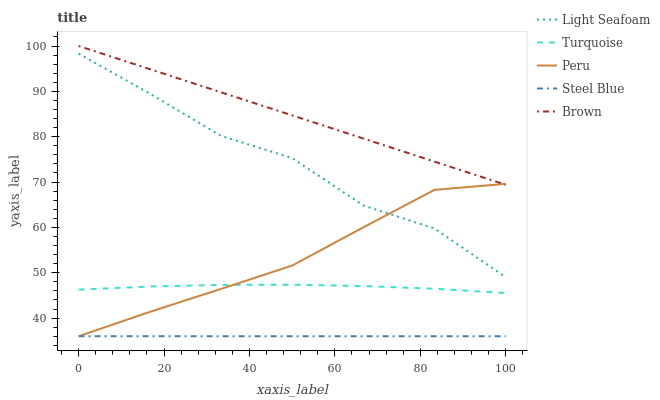Does Steel Blue have the minimum area under the curve?
Answer yes or no. Yes. Does Brown have the maximum area under the curve?
Answer yes or no. Yes. Does Turquoise have the minimum area under the curve?
Answer yes or no. No. Does Turquoise have the maximum area under the curve?
Answer yes or no. No. Is Brown the smoothest?
Answer yes or no. Yes. Is Light Seafoam the roughest?
Answer yes or no. Yes. Is Turquoise the smoothest?
Answer yes or no. No. Is Turquoise the roughest?
Answer yes or no. No. Does Turquoise have the lowest value?
Answer yes or no. No. Does Brown have the highest value?
Answer yes or no. Yes. Does Turquoise have the highest value?
Answer yes or no. No. Is Steel Blue less than Turquoise?
Answer yes or no. Yes. Is Brown greater than Turquoise?
Answer yes or no. Yes. Does Brown intersect Peru?
Answer yes or no. Yes. Is Brown less than Peru?
Answer yes or no. No. Is Brown greater than Peru?
Answer yes or no. No. Does Steel Blue intersect Turquoise?
Answer yes or no. No. 